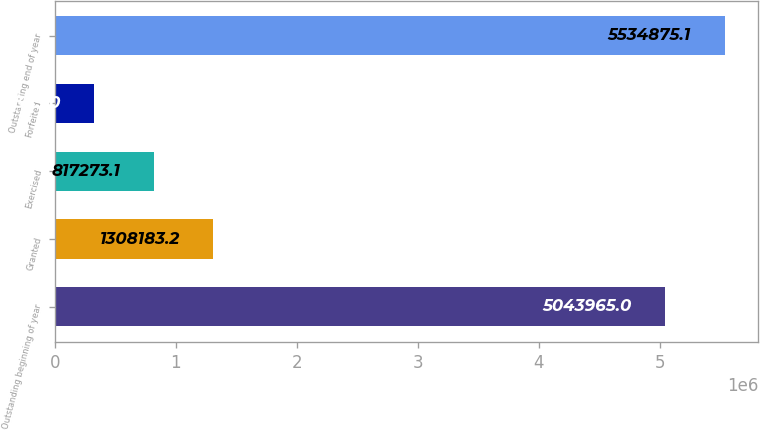<chart> <loc_0><loc_0><loc_500><loc_500><bar_chart><fcel>Outstanding beginning of year<fcel>Granted<fcel>Exercised<fcel>Forfeited<fcel>Outstanding end of year<nl><fcel>5.04396e+06<fcel>1.30818e+06<fcel>817273<fcel>326363<fcel>5.53488e+06<nl></chart> 